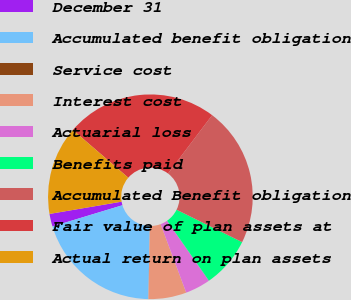Convert chart. <chart><loc_0><loc_0><loc_500><loc_500><pie_chart><fcel>December 31<fcel>Accumulated benefit obligation<fcel>Service cost<fcel>Interest cost<fcel>Actuarial loss<fcel>Benefits paid<fcel>Accumulated Benefit obligation<fcel>Fair value of plan assets at<fcel>Actual return on plan assets<nl><fcel>2.0%<fcel>20.0%<fcel>0.01%<fcel>6.0%<fcel>4.0%<fcel>8.0%<fcel>21.99%<fcel>23.99%<fcel>14.0%<nl></chart> 